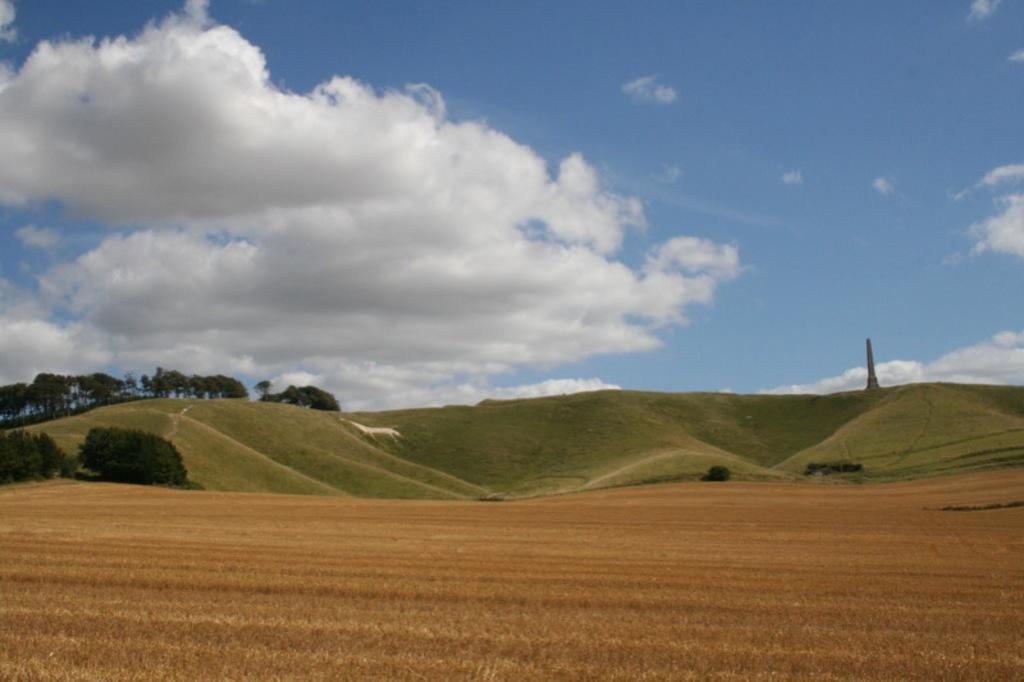What type of vegetation can be seen in the image? There are trees and plants in the image. What is on the ground in the image? There is grass on the ground in the image. What structure is present in the image? There is a tower in the image. What is the condition of the sky in the image? The sky is blue and cloudy in the image. How many clams can be seen on the tower in the image? There are no clams present in the image, and they are not associated with the tower. What part of the brain is visible in the image? There is no brain present in the image; it features trees, plants, a tower, grass, and a blue, cloudy sky. 